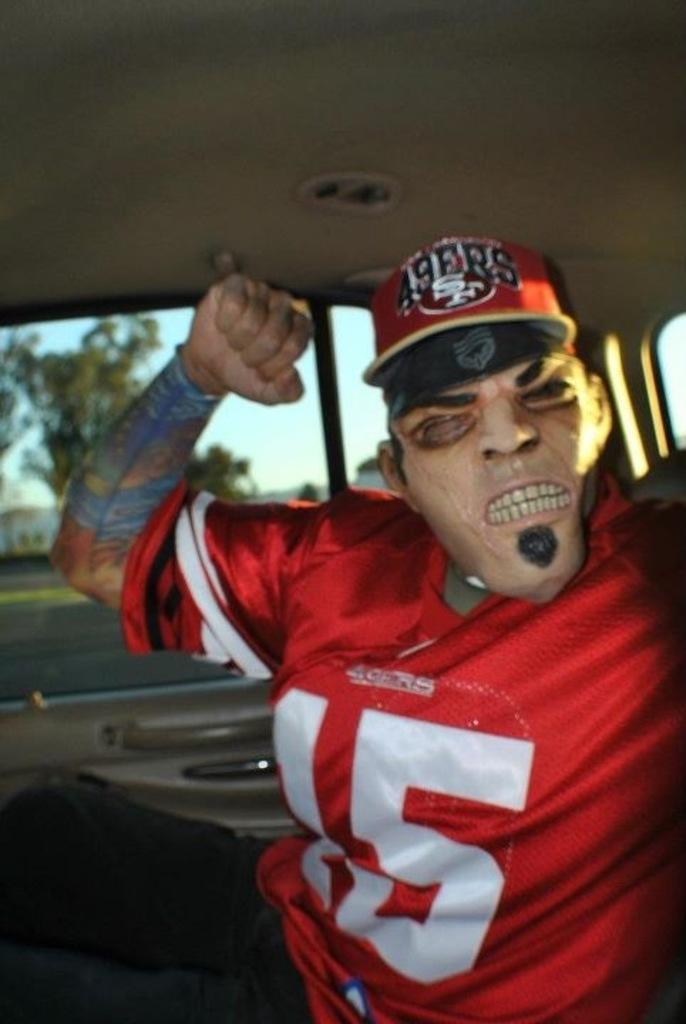Could you give a brief overview of what you see in this image? In this image, we can see a person is sitting inside the vehicle and wearing mask and cap. Here we can see glass objects and handles. Through the glasses, we can see the outside view. Here we can see trees, road and sky 